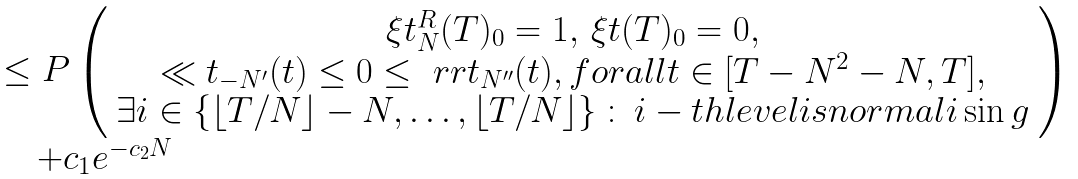<formula> <loc_0><loc_0><loc_500><loc_500>\begin{array} { l } \leq P \left ( \begin{array} { c } \xi t ^ { R } _ { N } ( T ) _ { 0 } = 1 , \, \xi t ( T ) _ { 0 } = 0 , \\ \ll t _ { - N ^ { \prime } } ( t ) \leq 0 \leq \ r r t _ { N ^ { \prime \prime } } ( t ) , f o r a l l t \in [ T - N ^ { 2 } - N , T ] , \\ \exists i \in \{ \lfloor T / N \rfloor - N , \dots , \lfloor T / N \rfloor \} \, \colon \, i - t h l e v e l i s n o r m a l i \sin g \end{array} \right ) \\ \quad + c _ { 1 } e ^ { - c _ { 2 } N } \end{array}</formula> 